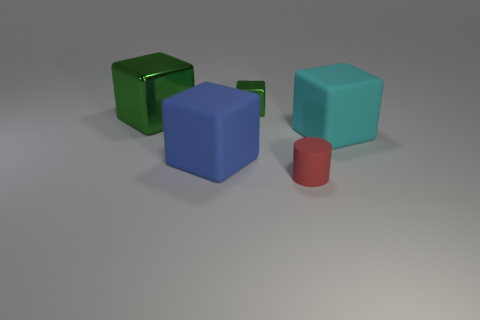Subtract all large green blocks. How many blocks are left? 3 Subtract all cylinders. How many objects are left? 4 Subtract 1 cubes. How many cubes are left? 3 Subtract all yellow cylinders. Subtract all purple blocks. How many cylinders are left? 1 Subtract all green cubes. How many yellow cylinders are left? 0 Subtract all small blue spheres. Subtract all large green things. How many objects are left? 4 Add 5 green metal blocks. How many green metal blocks are left? 7 Add 1 red metallic cubes. How many red metallic cubes exist? 1 Add 2 blue things. How many objects exist? 7 Subtract all cyan cubes. How many cubes are left? 3 